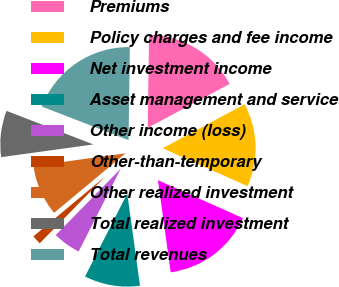<chart> <loc_0><loc_0><loc_500><loc_500><pie_chart><fcel>Premiums<fcel>Policy charges and fee income<fcel>Net investment income<fcel>Asset management and service<fcel>Other income (loss)<fcel>Other-than-temporary<fcel>Other realized investment<fcel>Total realized investment<fcel>Total revenues<nl><fcel>16.94%<fcel>14.52%<fcel>16.13%<fcel>9.68%<fcel>4.84%<fcel>1.61%<fcel>8.87%<fcel>8.06%<fcel>19.35%<nl></chart> 